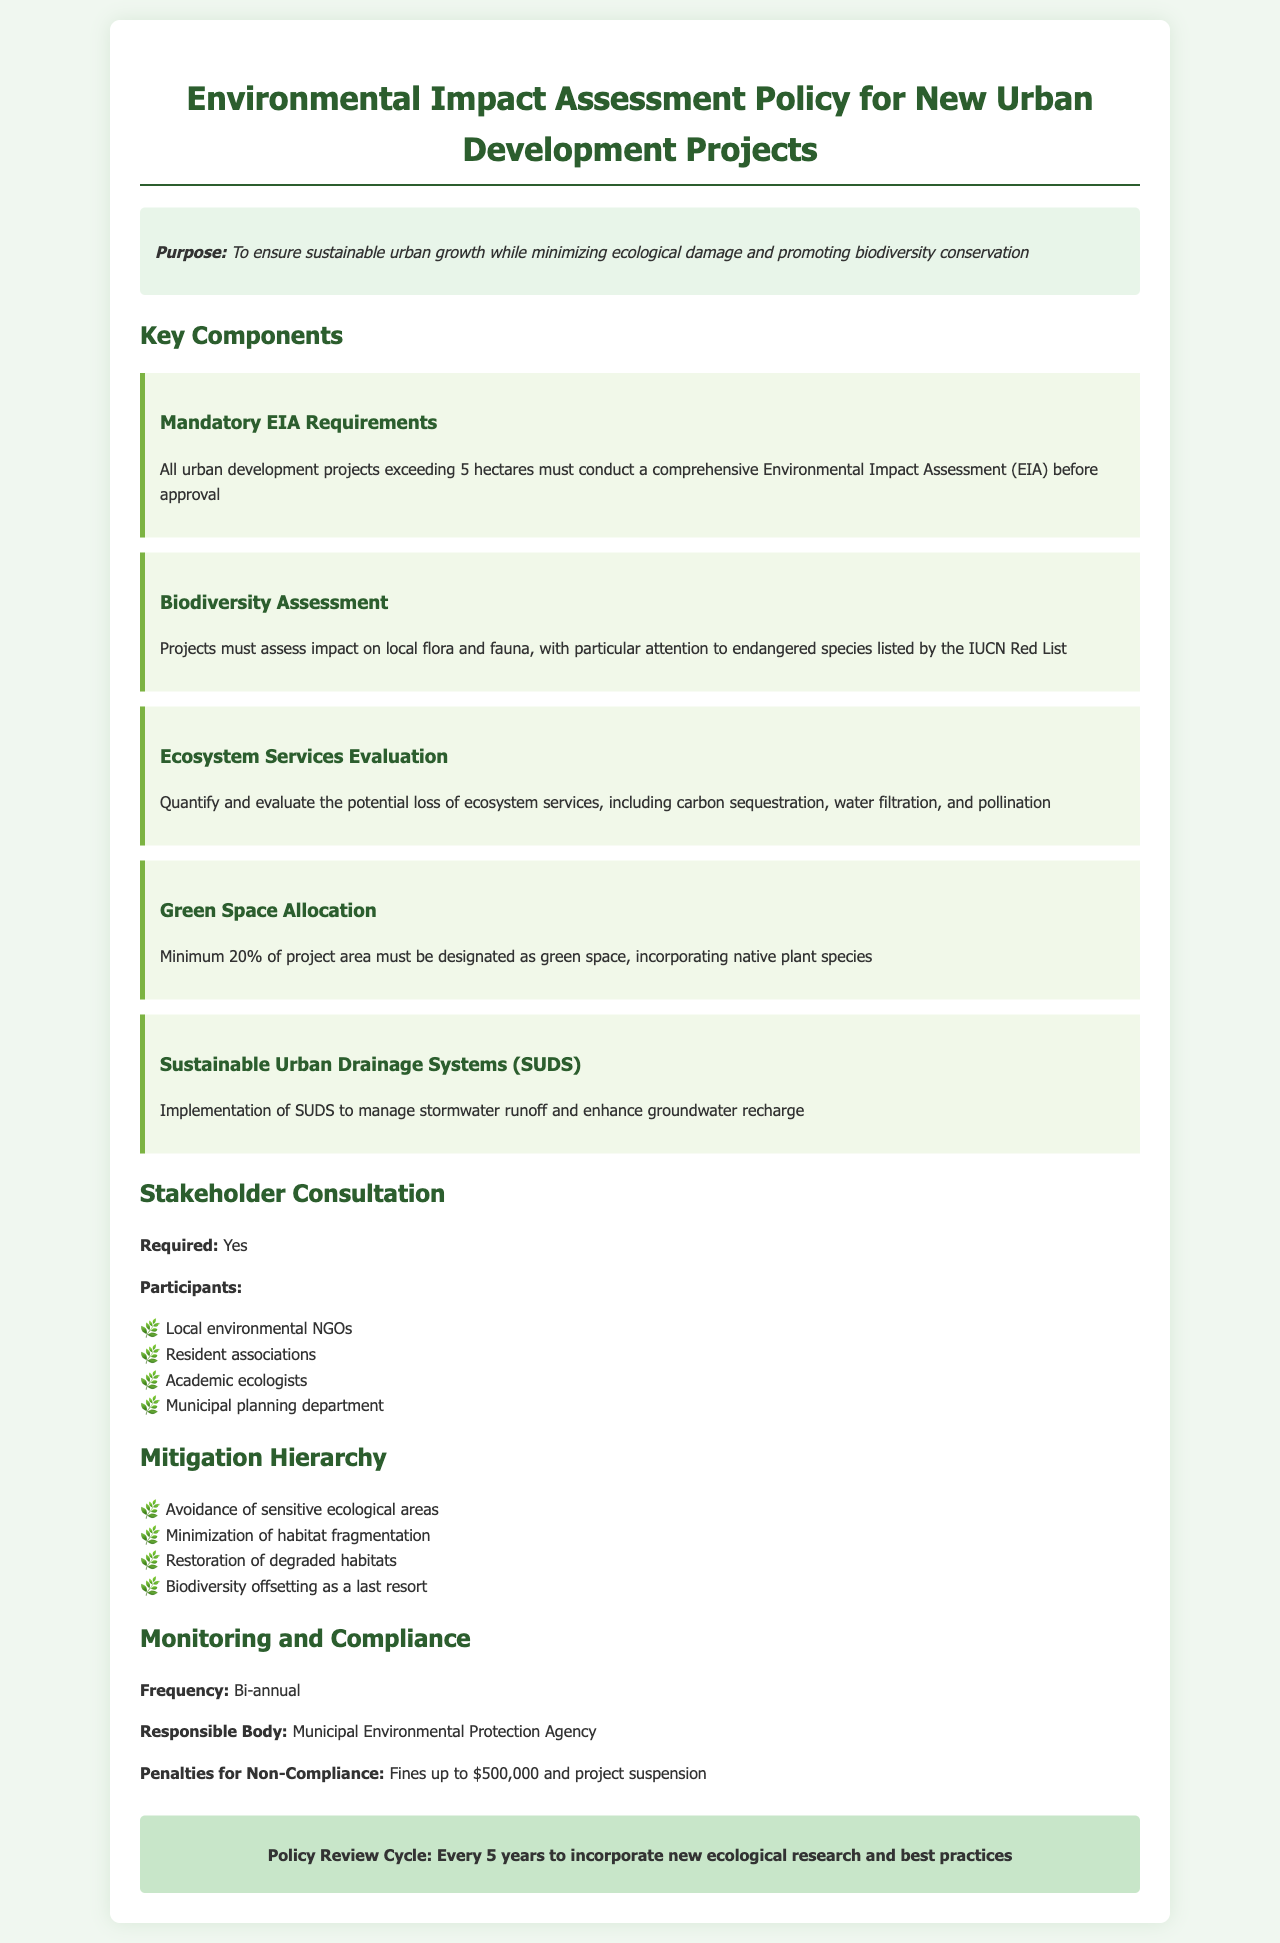What is the purpose of the policy? The purpose is to ensure sustainable urban growth while minimizing ecological damage and promoting biodiversity conservation.
Answer: To ensure sustainable urban growth while minimizing ecological damage and promoting biodiversity conservation What is the minimum area for projects to require an EIA? The document states that all urban development projects exceeding this area must conduct a comprehensive EIA.
Answer: 5 hectares What percentage of the project area must be designated as green space? The policy specifies the minimum percentage required for green space allocation within a development project.
Answer: 20% Who is responsible for monitoring and compliance? Information in the document identifies the agency that oversees the monitoring and compliance of the EIA policy.
Answer: Municipal Environmental Protection Agency How often must monitoring be conducted? The document specifies the frequency of monitoring for projects to ensure compliance with the policy.
Answer: Bi-annual What are the penalties for non-compliance? The document outlines the consequences that could be imposed if a project fails to adhere to the policy regulations.
Answer: Fines up to $500,000 and project suspension What is the first step in the mitigation hierarchy? The document enumerates steps in the mitigation hierarchy to address ecological impacts of development projects.
Answer: Avoidance of sensitive ecological areas Which stakeholders are required to participate in consultation? The document lists the participants involved in stakeholder consultation for the EIA process.
Answer: Local environmental NGOs, Resident associations, Academic ecologists, Municipal planning department How often will the policy be reviewed? The policy document specifies how frequently the review cycle occurs to update the regulations based on new research.
Answer: Every 5 years 